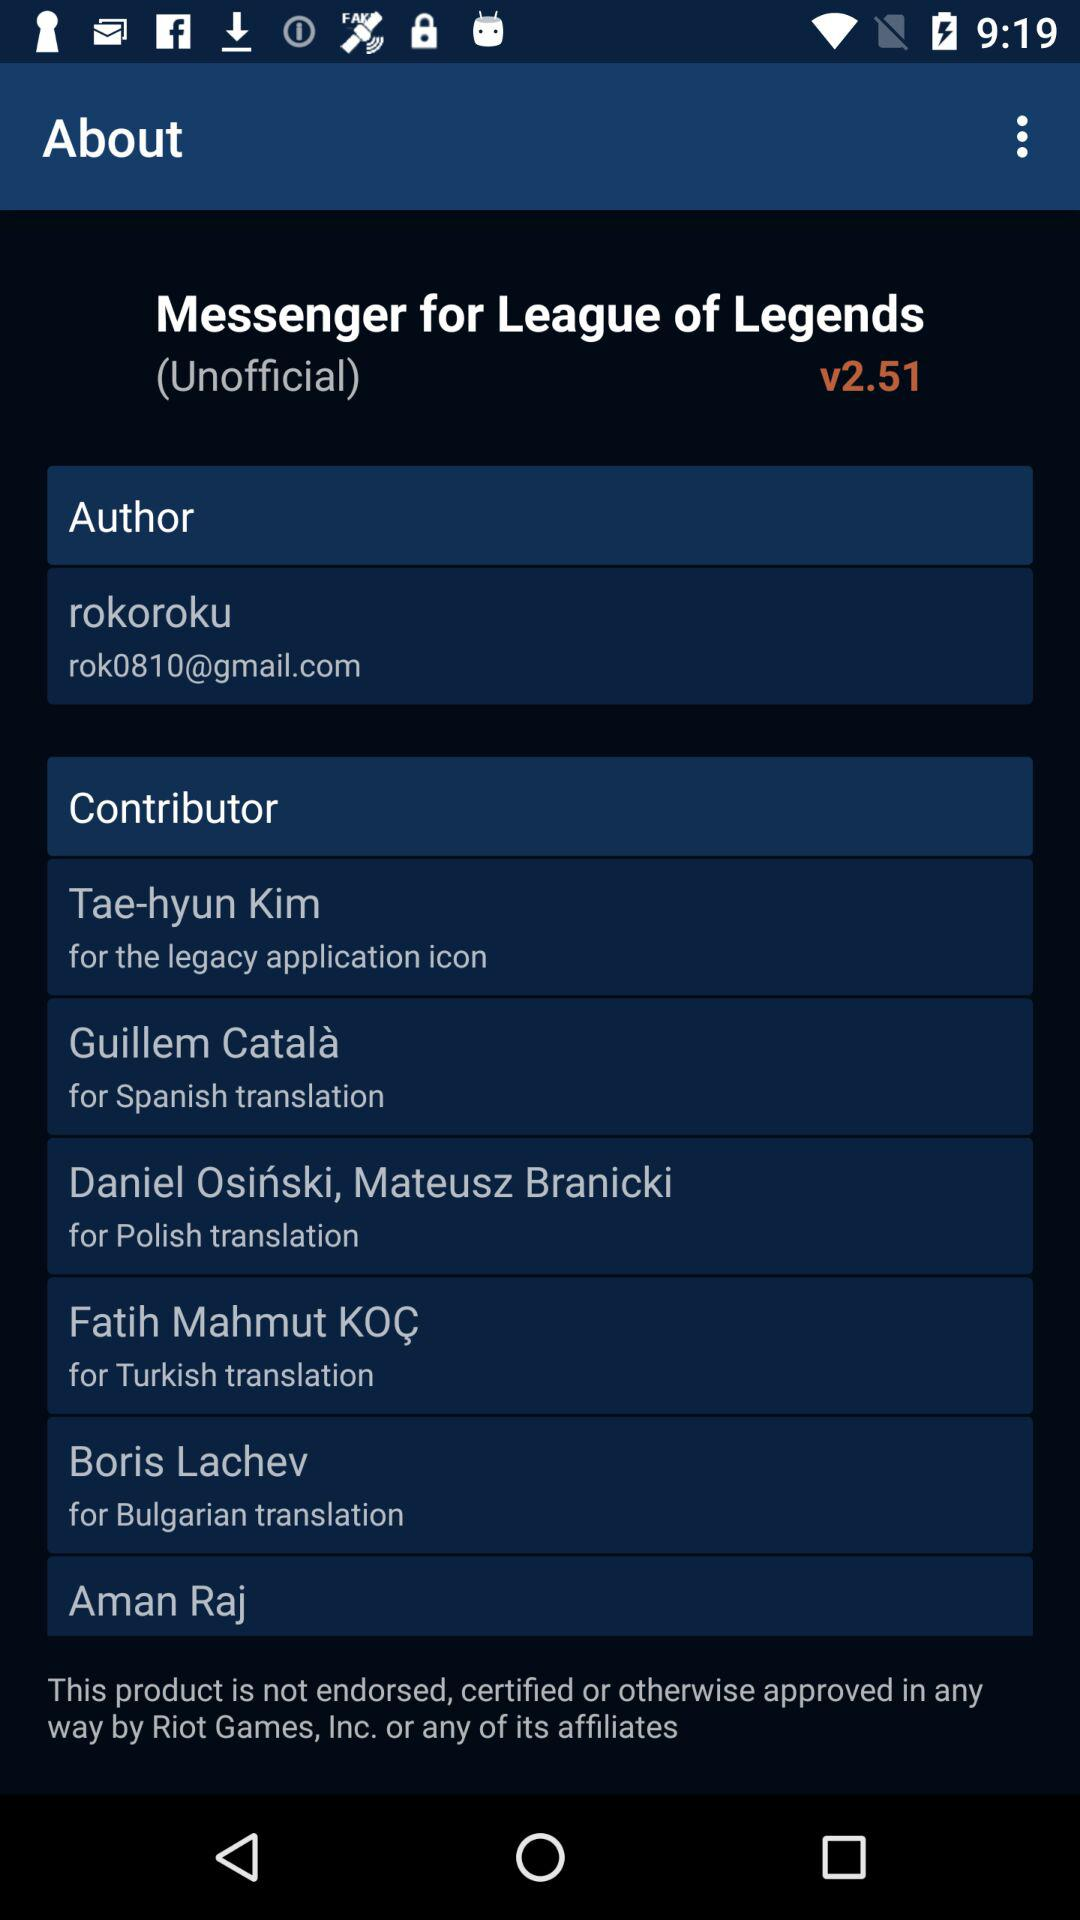What is the email address? The email address is rok0810@gmail.com. 